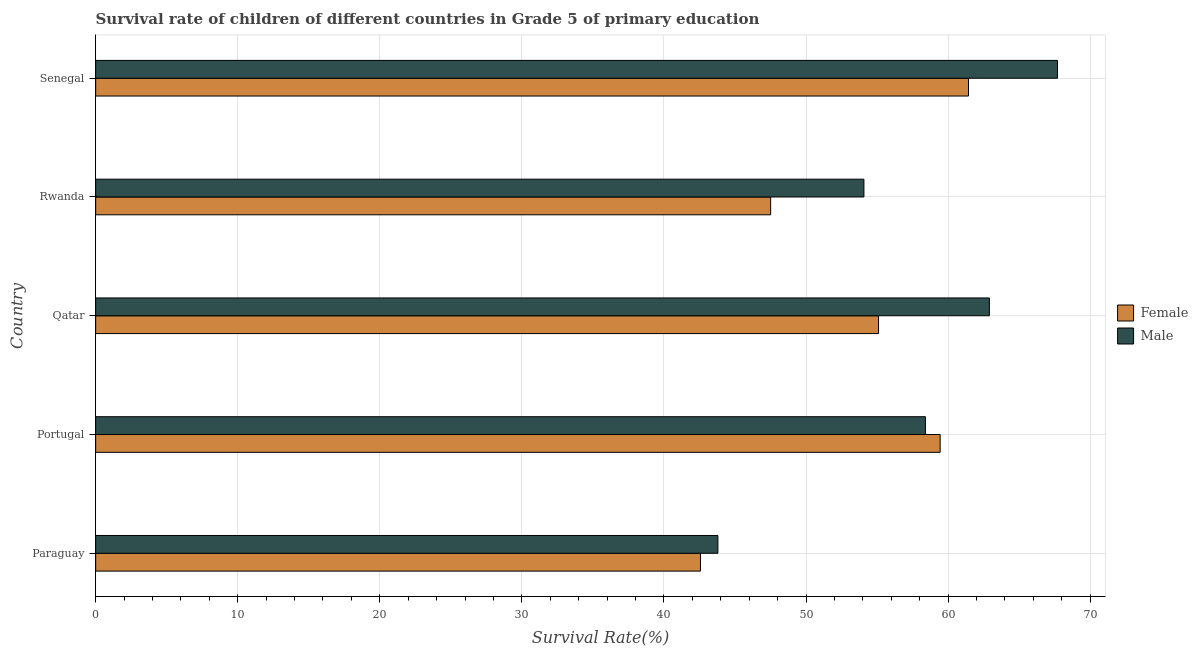How many bars are there on the 2nd tick from the top?
Ensure brevity in your answer.  2. What is the label of the 1st group of bars from the top?
Ensure brevity in your answer.  Senegal. In how many cases, is the number of bars for a given country not equal to the number of legend labels?
Provide a succinct answer. 0. What is the survival rate of male students in primary education in Qatar?
Make the answer very short. 62.9. Across all countries, what is the maximum survival rate of female students in primary education?
Your response must be concise. 61.43. Across all countries, what is the minimum survival rate of female students in primary education?
Offer a very short reply. 42.57. In which country was the survival rate of male students in primary education maximum?
Your answer should be very brief. Senegal. In which country was the survival rate of female students in primary education minimum?
Offer a terse response. Paraguay. What is the total survival rate of male students in primary education in the graph?
Your answer should be very brief. 286.87. What is the difference between the survival rate of male students in primary education in Portugal and that in Qatar?
Offer a very short reply. -4.5. What is the difference between the survival rate of female students in primary education in Paraguay and the survival rate of male students in primary education in Senegal?
Your answer should be compact. -25.13. What is the average survival rate of male students in primary education per country?
Make the answer very short. 57.37. What is the difference between the survival rate of female students in primary education and survival rate of male students in primary education in Senegal?
Your answer should be compact. -6.26. In how many countries, is the survival rate of male students in primary education greater than 44 %?
Keep it short and to the point. 4. What is the ratio of the survival rate of male students in primary education in Paraguay to that in Rwanda?
Provide a succinct answer. 0.81. Is the survival rate of male students in primary education in Paraguay less than that in Rwanda?
Ensure brevity in your answer.  Yes. Is the difference between the survival rate of female students in primary education in Rwanda and Senegal greater than the difference between the survival rate of male students in primary education in Rwanda and Senegal?
Your response must be concise. No. What is the difference between the highest and the second highest survival rate of female students in primary education?
Offer a terse response. 2. What is the difference between the highest and the lowest survival rate of female students in primary education?
Keep it short and to the point. 18.87. In how many countries, is the survival rate of female students in primary education greater than the average survival rate of female students in primary education taken over all countries?
Give a very brief answer. 3. Is the sum of the survival rate of female students in primary education in Rwanda and Senegal greater than the maximum survival rate of male students in primary education across all countries?
Give a very brief answer. Yes. What does the 1st bar from the top in Paraguay represents?
Offer a terse response. Male. What does the 2nd bar from the bottom in Qatar represents?
Provide a short and direct response. Male. What is the difference between two consecutive major ticks on the X-axis?
Offer a terse response. 10. What is the title of the graph?
Offer a very short reply. Survival rate of children of different countries in Grade 5 of primary education. Does "Investment in Telecom" appear as one of the legend labels in the graph?
Keep it short and to the point. No. What is the label or title of the X-axis?
Ensure brevity in your answer.  Survival Rate(%). What is the label or title of the Y-axis?
Provide a short and direct response. Country. What is the Survival Rate(%) of Female in Paraguay?
Provide a short and direct response. 42.57. What is the Survival Rate(%) of Male in Paraguay?
Your response must be concise. 43.79. What is the Survival Rate(%) of Female in Portugal?
Offer a terse response. 59.44. What is the Survival Rate(%) in Male in Portugal?
Give a very brief answer. 58.4. What is the Survival Rate(%) in Female in Qatar?
Give a very brief answer. 55.1. What is the Survival Rate(%) in Male in Qatar?
Provide a short and direct response. 62.9. What is the Survival Rate(%) in Female in Rwanda?
Give a very brief answer. 47.51. What is the Survival Rate(%) of Male in Rwanda?
Offer a very short reply. 54.07. What is the Survival Rate(%) in Female in Senegal?
Give a very brief answer. 61.43. What is the Survival Rate(%) in Male in Senegal?
Offer a terse response. 67.7. Across all countries, what is the maximum Survival Rate(%) in Female?
Your response must be concise. 61.43. Across all countries, what is the maximum Survival Rate(%) in Male?
Your answer should be very brief. 67.7. Across all countries, what is the minimum Survival Rate(%) of Female?
Your answer should be very brief. 42.57. Across all countries, what is the minimum Survival Rate(%) in Male?
Your answer should be very brief. 43.79. What is the total Survival Rate(%) of Female in the graph?
Ensure brevity in your answer.  266.05. What is the total Survival Rate(%) of Male in the graph?
Your answer should be compact. 286.87. What is the difference between the Survival Rate(%) of Female in Paraguay and that in Portugal?
Your response must be concise. -16.87. What is the difference between the Survival Rate(%) of Male in Paraguay and that in Portugal?
Keep it short and to the point. -14.61. What is the difference between the Survival Rate(%) of Female in Paraguay and that in Qatar?
Your answer should be very brief. -12.53. What is the difference between the Survival Rate(%) of Male in Paraguay and that in Qatar?
Your answer should be compact. -19.11. What is the difference between the Survival Rate(%) in Female in Paraguay and that in Rwanda?
Offer a very short reply. -4.94. What is the difference between the Survival Rate(%) of Male in Paraguay and that in Rwanda?
Offer a very short reply. -10.28. What is the difference between the Survival Rate(%) of Female in Paraguay and that in Senegal?
Your answer should be compact. -18.87. What is the difference between the Survival Rate(%) of Male in Paraguay and that in Senegal?
Ensure brevity in your answer.  -23.9. What is the difference between the Survival Rate(%) in Female in Portugal and that in Qatar?
Ensure brevity in your answer.  4.34. What is the difference between the Survival Rate(%) of Male in Portugal and that in Qatar?
Make the answer very short. -4.5. What is the difference between the Survival Rate(%) of Female in Portugal and that in Rwanda?
Your answer should be compact. 11.93. What is the difference between the Survival Rate(%) of Male in Portugal and that in Rwanda?
Make the answer very short. 4.33. What is the difference between the Survival Rate(%) of Female in Portugal and that in Senegal?
Your response must be concise. -1.99. What is the difference between the Survival Rate(%) in Male in Portugal and that in Senegal?
Ensure brevity in your answer.  -9.29. What is the difference between the Survival Rate(%) of Female in Qatar and that in Rwanda?
Offer a terse response. 7.59. What is the difference between the Survival Rate(%) of Male in Qatar and that in Rwanda?
Your answer should be very brief. 8.83. What is the difference between the Survival Rate(%) in Female in Qatar and that in Senegal?
Keep it short and to the point. -6.33. What is the difference between the Survival Rate(%) of Male in Qatar and that in Senegal?
Ensure brevity in your answer.  -4.79. What is the difference between the Survival Rate(%) in Female in Rwanda and that in Senegal?
Your response must be concise. -13.93. What is the difference between the Survival Rate(%) in Male in Rwanda and that in Senegal?
Your response must be concise. -13.62. What is the difference between the Survival Rate(%) in Female in Paraguay and the Survival Rate(%) in Male in Portugal?
Ensure brevity in your answer.  -15.84. What is the difference between the Survival Rate(%) in Female in Paraguay and the Survival Rate(%) in Male in Qatar?
Ensure brevity in your answer.  -20.34. What is the difference between the Survival Rate(%) of Female in Paraguay and the Survival Rate(%) of Male in Rwanda?
Offer a very short reply. -11.51. What is the difference between the Survival Rate(%) in Female in Paraguay and the Survival Rate(%) in Male in Senegal?
Offer a terse response. -25.13. What is the difference between the Survival Rate(%) in Female in Portugal and the Survival Rate(%) in Male in Qatar?
Provide a succinct answer. -3.47. What is the difference between the Survival Rate(%) of Female in Portugal and the Survival Rate(%) of Male in Rwanda?
Keep it short and to the point. 5.37. What is the difference between the Survival Rate(%) in Female in Portugal and the Survival Rate(%) in Male in Senegal?
Make the answer very short. -8.26. What is the difference between the Survival Rate(%) in Female in Qatar and the Survival Rate(%) in Male in Rwanda?
Make the answer very short. 1.03. What is the difference between the Survival Rate(%) of Female in Qatar and the Survival Rate(%) of Male in Senegal?
Give a very brief answer. -12.6. What is the difference between the Survival Rate(%) in Female in Rwanda and the Survival Rate(%) in Male in Senegal?
Offer a terse response. -20.19. What is the average Survival Rate(%) of Female per country?
Your response must be concise. 53.21. What is the average Survival Rate(%) in Male per country?
Give a very brief answer. 57.37. What is the difference between the Survival Rate(%) in Female and Survival Rate(%) in Male in Paraguay?
Keep it short and to the point. -1.23. What is the difference between the Survival Rate(%) in Female and Survival Rate(%) in Male in Portugal?
Your answer should be compact. 1.04. What is the difference between the Survival Rate(%) in Female and Survival Rate(%) in Male in Qatar?
Make the answer very short. -7.8. What is the difference between the Survival Rate(%) in Female and Survival Rate(%) in Male in Rwanda?
Your answer should be very brief. -6.57. What is the difference between the Survival Rate(%) in Female and Survival Rate(%) in Male in Senegal?
Make the answer very short. -6.26. What is the ratio of the Survival Rate(%) of Female in Paraguay to that in Portugal?
Offer a very short reply. 0.72. What is the ratio of the Survival Rate(%) of Male in Paraguay to that in Portugal?
Give a very brief answer. 0.75. What is the ratio of the Survival Rate(%) in Female in Paraguay to that in Qatar?
Offer a very short reply. 0.77. What is the ratio of the Survival Rate(%) in Male in Paraguay to that in Qatar?
Provide a succinct answer. 0.7. What is the ratio of the Survival Rate(%) of Female in Paraguay to that in Rwanda?
Provide a succinct answer. 0.9. What is the ratio of the Survival Rate(%) in Male in Paraguay to that in Rwanda?
Offer a very short reply. 0.81. What is the ratio of the Survival Rate(%) in Female in Paraguay to that in Senegal?
Give a very brief answer. 0.69. What is the ratio of the Survival Rate(%) in Male in Paraguay to that in Senegal?
Your answer should be compact. 0.65. What is the ratio of the Survival Rate(%) of Female in Portugal to that in Qatar?
Ensure brevity in your answer.  1.08. What is the ratio of the Survival Rate(%) of Male in Portugal to that in Qatar?
Keep it short and to the point. 0.93. What is the ratio of the Survival Rate(%) of Female in Portugal to that in Rwanda?
Your answer should be compact. 1.25. What is the ratio of the Survival Rate(%) in Male in Portugal to that in Rwanda?
Give a very brief answer. 1.08. What is the ratio of the Survival Rate(%) of Female in Portugal to that in Senegal?
Keep it short and to the point. 0.97. What is the ratio of the Survival Rate(%) of Male in Portugal to that in Senegal?
Ensure brevity in your answer.  0.86. What is the ratio of the Survival Rate(%) in Female in Qatar to that in Rwanda?
Offer a terse response. 1.16. What is the ratio of the Survival Rate(%) in Male in Qatar to that in Rwanda?
Ensure brevity in your answer.  1.16. What is the ratio of the Survival Rate(%) in Female in Qatar to that in Senegal?
Provide a succinct answer. 0.9. What is the ratio of the Survival Rate(%) of Male in Qatar to that in Senegal?
Give a very brief answer. 0.93. What is the ratio of the Survival Rate(%) in Female in Rwanda to that in Senegal?
Your response must be concise. 0.77. What is the ratio of the Survival Rate(%) in Male in Rwanda to that in Senegal?
Provide a short and direct response. 0.8. What is the difference between the highest and the second highest Survival Rate(%) in Female?
Your response must be concise. 1.99. What is the difference between the highest and the second highest Survival Rate(%) of Male?
Offer a terse response. 4.79. What is the difference between the highest and the lowest Survival Rate(%) of Female?
Make the answer very short. 18.87. What is the difference between the highest and the lowest Survival Rate(%) in Male?
Offer a terse response. 23.9. 